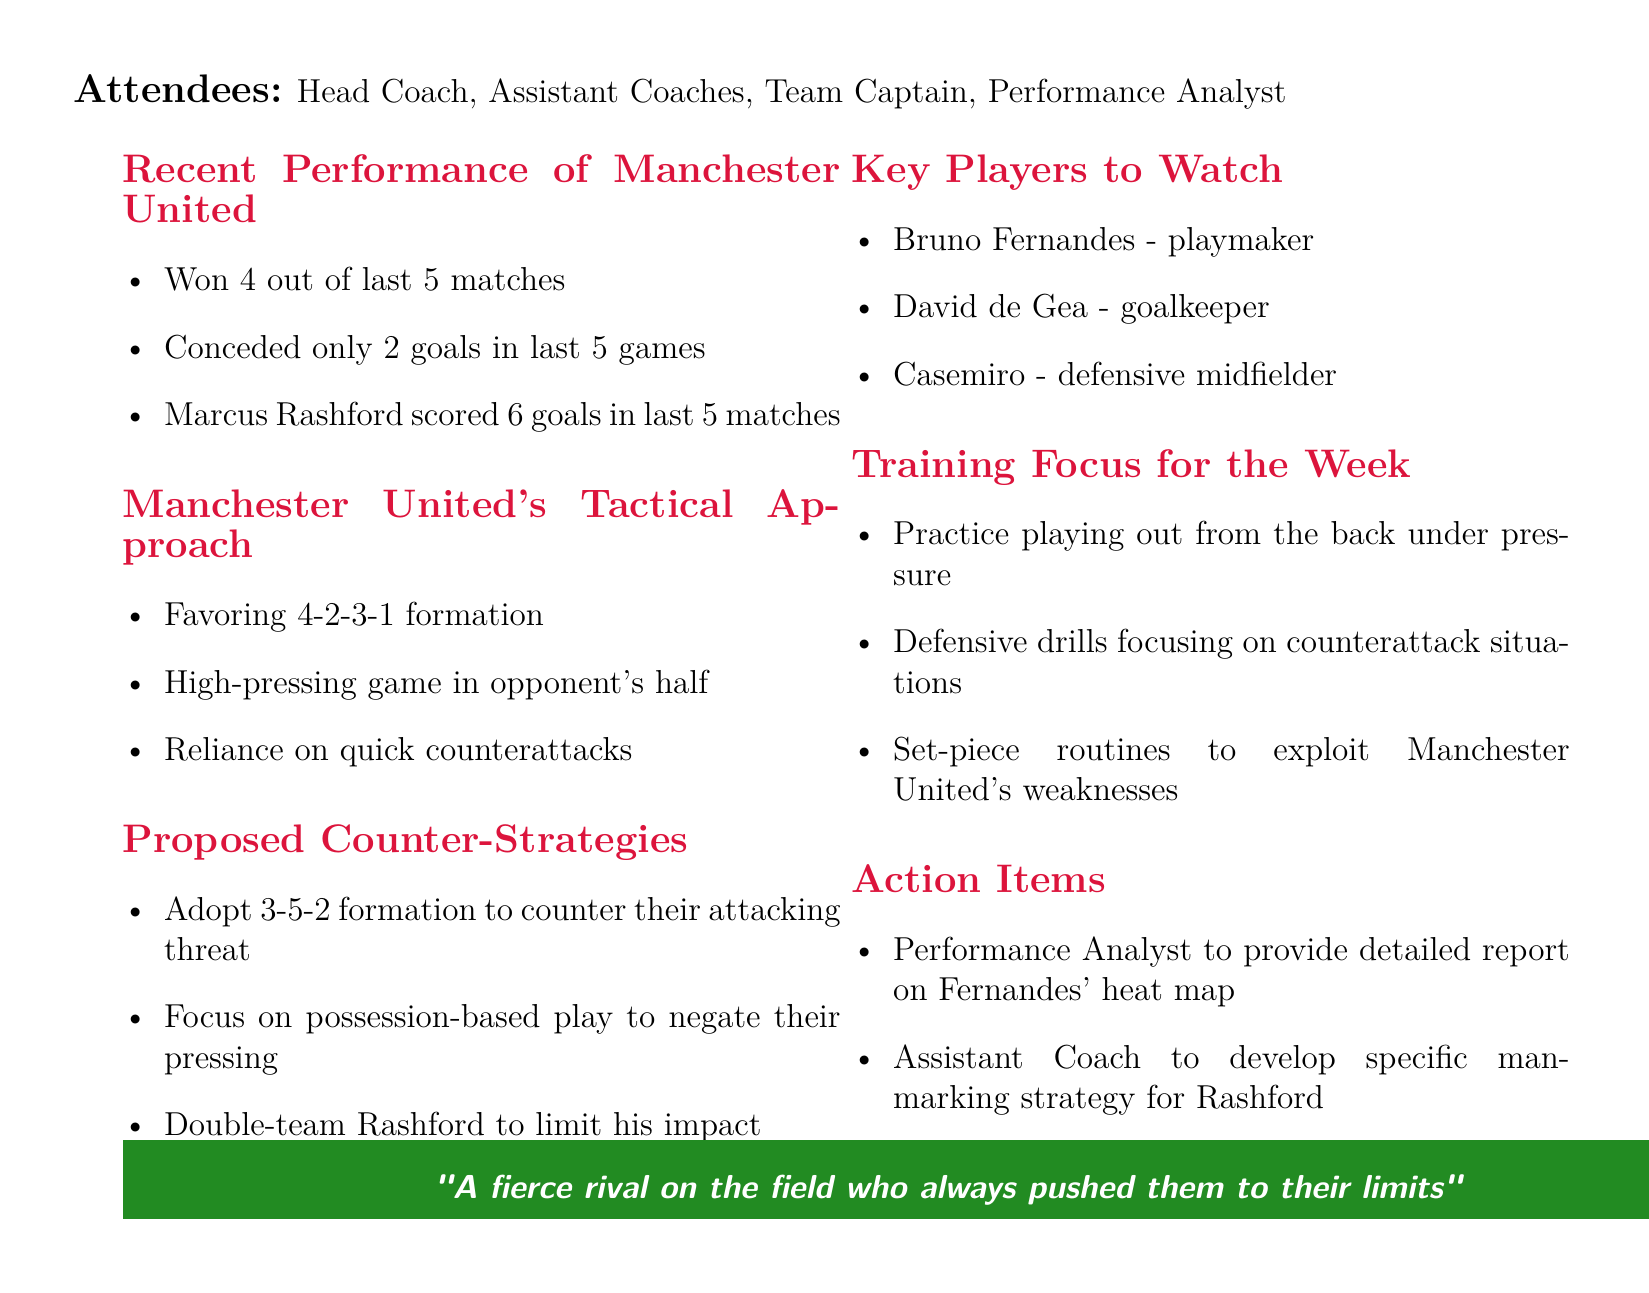What is the date of the meeting? The date of the meeting is specifically stated in the document.
Answer: 2023-05-15 How many matches did Manchester United win recently? This information is detailed under the "Recent Performance of Manchester United" section in the document.
Answer: 4 What formation does Manchester United favor? This detail is specified in the "Manchester United's Tactical Approach" section.
Answer: 4-2-3-1 Who is the key player mentioned as a playmaker? This is noted under the "Key Players to Watch" section.
Answer: Bruno Fernandes What is the proposed counter-strategy for Rashford? This can be found in the "Proposed Counter-Strategies" section, addressing how to deal with Rashford’s performance.
Answer: Double-team Rashford to limit his impact What should the Team Captain lead extra practice sessions on? This is indicated in the "Action Items" section referring to specific tasks.
Answer: Set-piece practice sessions How many goals did Marcus Rashford score in the last 5 matches? This figure is provided in the "Recent Performance of Manchester United" section.
Answer: 6 What specific training focus involves playing under pressure? This detail is included in the "Training Focus for the Week" section addressing strategic training sessions.
Answer: Practice playing out from the back under pressure 